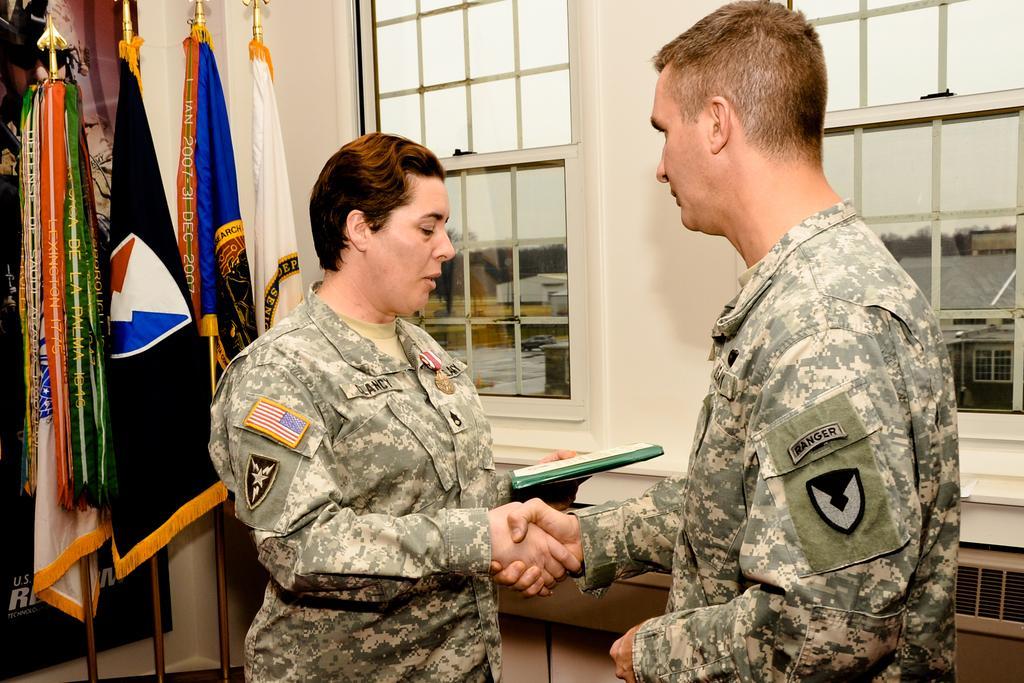Describe this image in one or two sentences. In this picture there is a woman who is wearing army uniform. In front of her there is a man who is also wearing army uniform. Both of them are shaking the hands. On the left I can see many flags which are placed near to the wall and window. Through the window I can see the shed, buildings, trees and sky. 